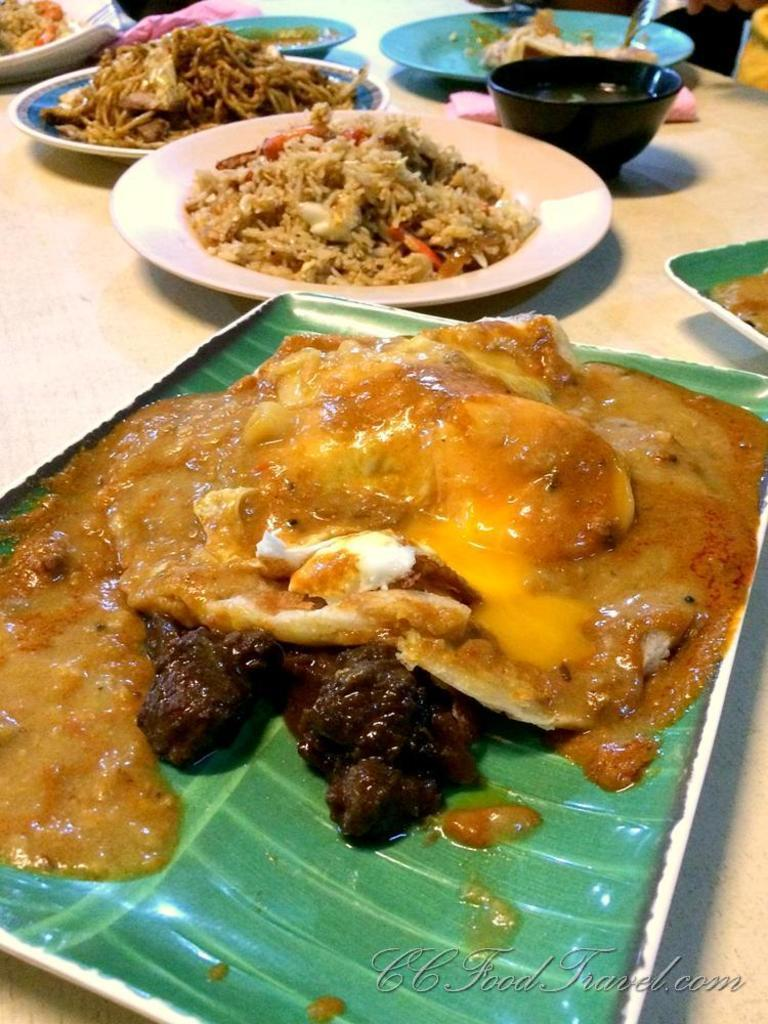What type of tableware can be seen on the table in the image? There are plates, a tray, and a bowl on the table in the image. What is the purpose of the tableware? The plates, tray, and bowl have food in them, suggesting they are being used for serving or eating. What utensil is present on the table? There is a fork on the table. Reasoning: Let'g: Let's think step by step in order to produce the conversation. We start by identifying the main objects on the table, which are the plates, tray, and bowl. Then, we describe their purpose, which is to hold food. Finally, we mention the presence of a fork, which is a fact provided. Absurd Question/Answer: What type of powder can be seen on the drum in the image? There is no drum or powder present in the image. The image only shows tableware with food on a table. 